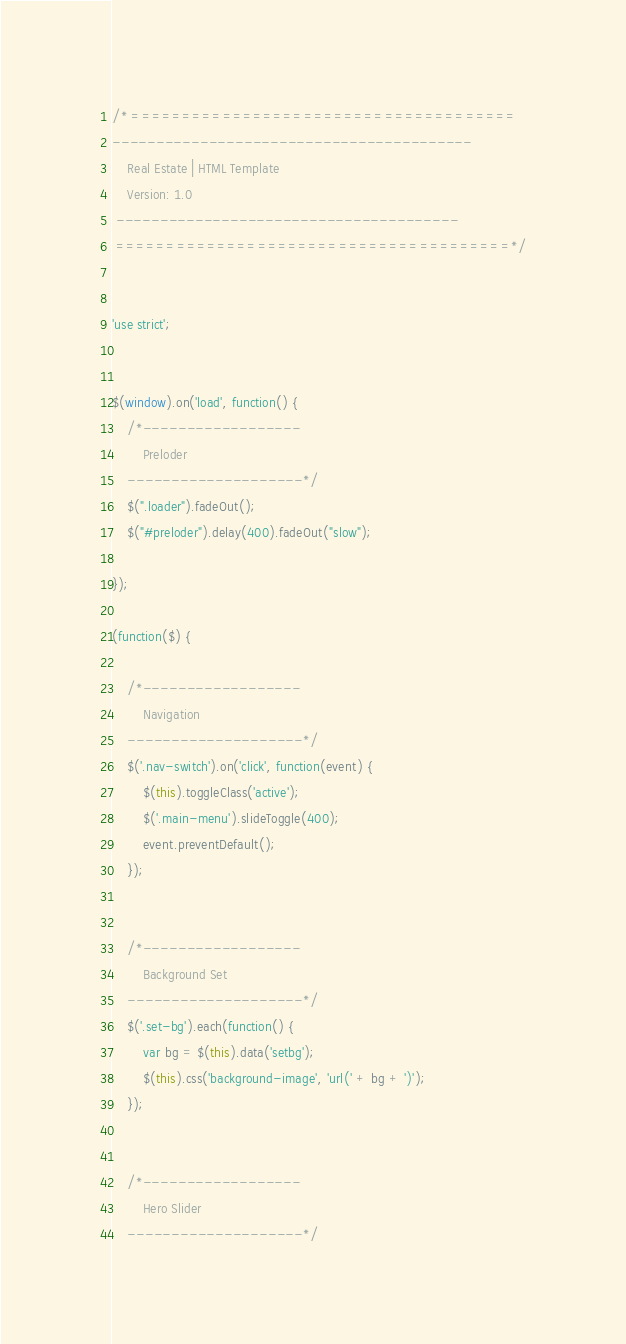Convert code to text. <code><loc_0><loc_0><loc_500><loc_500><_JavaScript_>/* ======================================
-----------------------------------------
	Real Estate | HTML Template
	Version: 1.0
 ---------------------------------------
 =======================================*/


'use strict';


$(window).on('load', function() {
	/*------------------
		Preloder
	--------------------*/
	$(".loader").fadeOut();
	$("#preloder").delay(400).fadeOut("slow");

});

(function($) {

	/*------------------
		Navigation
	--------------------*/
	$('.nav-switch').on('click', function(event) {
		$(this).toggleClass('active');
		$('.main-menu').slideToggle(400);
		event.preventDefault();
	});


	/*------------------
		Background Set
	--------------------*/
	$('.set-bg').each(function() {
		var bg = $(this).data('setbg');
		$(this).css('background-image', 'url(' + bg + ')');
	});


	/*------------------
		Hero Slider
	--------------------*/</code> 